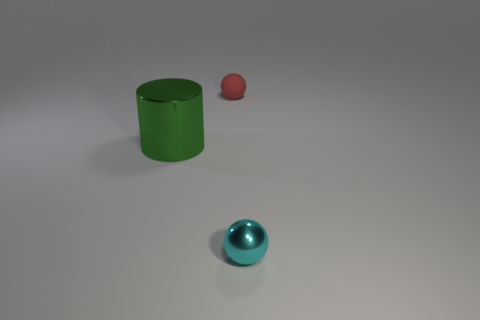There is a tiny cyan thing that is the same material as the large thing; what shape is it?
Your answer should be very brief. Sphere. What number of other objects are the same shape as the tiny matte object?
Your answer should be very brief. 1. There is a cyan metallic ball; what number of small cyan spheres are on the left side of it?
Make the answer very short. 0. There is a ball behind the small cyan metallic object; does it have the same size as the shiny thing that is on the left side of the tiny cyan thing?
Provide a succinct answer. No. What number of other objects are the same size as the red thing?
Provide a short and direct response. 1. What material is the ball that is in front of the sphere left of the cyan metallic sphere that is in front of the red ball?
Your answer should be very brief. Metal. There is a cyan thing; does it have the same size as the ball behind the metal sphere?
Your answer should be very brief. Yes. What size is the object that is both to the left of the tiny cyan sphere and in front of the red matte thing?
Offer a terse response. Large. What color is the sphere on the left side of the sphere in front of the red object?
Your answer should be compact. Red. Is the number of red things right of the tiny red matte sphere less than the number of cylinders that are on the left side of the metal sphere?
Offer a very short reply. Yes. 